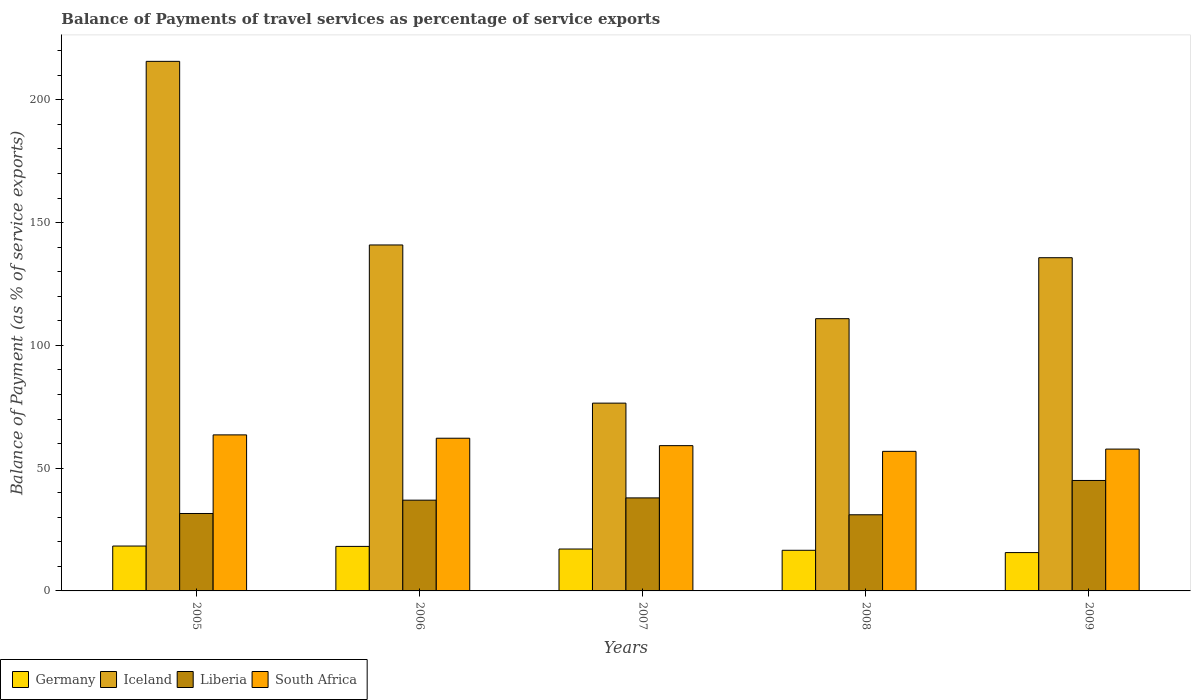How many different coloured bars are there?
Offer a terse response. 4. How many groups of bars are there?
Your answer should be compact. 5. What is the label of the 4th group of bars from the left?
Provide a succinct answer. 2008. What is the balance of payments of travel services in Germany in 2008?
Make the answer very short. 16.55. Across all years, what is the maximum balance of payments of travel services in South Africa?
Your response must be concise. 63.54. Across all years, what is the minimum balance of payments of travel services in South Africa?
Provide a short and direct response. 56.83. In which year was the balance of payments of travel services in Iceland minimum?
Give a very brief answer. 2007. What is the total balance of payments of travel services in Germany in the graph?
Give a very brief answer. 85.63. What is the difference between the balance of payments of travel services in Germany in 2005 and that in 2007?
Offer a terse response. 1.21. What is the difference between the balance of payments of travel services in Germany in 2005 and the balance of payments of travel services in Iceland in 2006?
Ensure brevity in your answer.  -122.6. What is the average balance of payments of travel services in Iceland per year?
Provide a succinct answer. 135.91. In the year 2009, what is the difference between the balance of payments of travel services in South Africa and balance of payments of travel services in Germany?
Provide a succinct answer. 42.15. In how many years, is the balance of payments of travel services in Liberia greater than 200 %?
Offer a very short reply. 0. What is the ratio of the balance of payments of travel services in Germany in 2005 to that in 2008?
Ensure brevity in your answer.  1.1. Is the balance of payments of travel services in Germany in 2005 less than that in 2007?
Provide a short and direct response. No. What is the difference between the highest and the second highest balance of payments of travel services in Germany?
Provide a short and direct response. 0.14. What is the difference between the highest and the lowest balance of payments of travel services in Germany?
Your answer should be very brief. 2.67. What does the 4th bar from the left in 2009 represents?
Offer a terse response. South Africa. What does the 3rd bar from the right in 2008 represents?
Your answer should be compact. Iceland. How many bars are there?
Make the answer very short. 20. Are all the bars in the graph horizontal?
Provide a succinct answer. No. How many years are there in the graph?
Give a very brief answer. 5. Are the values on the major ticks of Y-axis written in scientific E-notation?
Offer a terse response. No. Does the graph contain grids?
Ensure brevity in your answer.  No. Where does the legend appear in the graph?
Offer a terse response. Bottom left. How are the legend labels stacked?
Provide a succinct answer. Horizontal. What is the title of the graph?
Keep it short and to the point. Balance of Payments of travel services as percentage of service exports. What is the label or title of the X-axis?
Keep it short and to the point. Years. What is the label or title of the Y-axis?
Provide a short and direct response. Balance of Payment (as % of service exports). What is the Balance of Payment (as % of service exports) of Germany in 2005?
Make the answer very short. 18.28. What is the Balance of Payment (as % of service exports) in Iceland in 2005?
Your response must be concise. 215.64. What is the Balance of Payment (as % of service exports) of Liberia in 2005?
Provide a succinct answer. 31.53. What is the Balance of Payment (as % of service exports) in South Africa in 2005?
Ensure brevity in your answer.  63.54. What is the Balance of Payment (as % of service exports) of Germany in 2006?
Offer a very short reply. 18.13. What is the Balance of Payment (as % of service exports) of Iceland in 2006?
Keep it short and to the point. 140.88. What is the Balance of Payment (as % of service exports) in Liberia in 2006?
Offer a very short reply. 36.96. What is the Balance of Payment (as % of service exports) in South Africa in 2006?
Offer a very short reply. 62.18. What is the Balance of Payment (as % of service exports) of Germany in 2007?
Make the answer very short. 17.06. What is the Balance of Payment (as % of service exports) of Iceland in 2007?
Ensure brevity in your answer.  76.47. What is the Balance of Payment (as % of service exports) of Liberia in 2007?
Ensure brevity in your answer.  37.88. What is the Balance of Payment (as % of service exports) of South Africa in 2007?
Make the answer very short. 59.16. What is the Balance of Payment (as % of service exports) of Germany in 2008?
Your answer should be compact. 16.55. What is the Balance of Payment (as % of service exports) in Iceland in 2008?
Provide a short and direct response. 110.86. What is the Balance of Payment (as % of service exports) in Liberia in 2008?
Your answer should be compact. 31.01. What is the Balance of Payment (as % of service exports) in South Africa in 2008?
Provide a succinct answer. 56.83. What is the Balance of Payment (as % of service exports) in Germany in 2009?
Keep it short and to the point. 15.61. What is the Balance of Payment (as % of service exports) in Iceland in 2009?
Your response must be concise. 135.69. What is the Balance of Payment (as % of service exports) of Liberia in 2009?
Give a very brief answer. 44.98. What is the Balance of Payment (as % of service exports) of South Africa in 2009?
Ensure brevity in your answer.  57.76. Across all years, what is the maximum Balance of Payment (as % of service exports) of Germany?
Provide a short and direct response. 18.28. Across all years, what is the maximum Balance of Payment (as % of service exports) of Iceland?
Offer a terse response. 215.64. Across all years, what is the maximum Balance of Payment (as % of service exports) in Liberia?
Your answer should be very brief. 44.98. Across all years, what is the maximum Balance of Payment (as % of service exports) in South Africa?
Your answer should be very brief. 63.54. Across all years, what is the minimum Balance of Payment (as % of service exports) of Germany?
Ensure brevity in your answer.  15.61. Across all years, what is the minimum Balance of Payment (as % of service exports) in Iceland?
Your answer should be very brief. 76.47. Across all years, what is the minimum Balance of Payment (as % of service exports) in Liberia?
Keep it short and to the point. 31.01. Across all years, what is the minimum Balance of Payment (as % of service exports) of South Africa?
Your answer should be compact. 56.83. What is the total Balance of Payment (as % of service exports) in Germany in the graph?
Your answer should be compact. 85.63. What is the total Balance of Payment (as % of service exports) of Iceland in the graph?
Offer a terse response. 679.54. What is the total Balance of Payment (as % of service exports) in Liberia in the graph?
Your answer should be compact. 182.36. What is the total Balance of Payment (as % of service exports) in South Africa in the graph?
Provide a succinct answer. 299.47. What is the difference between the Balance of Payment (as % of service exports) in Germany in 2005 and that in 2006?
Offer a terse response. 0.14. What is the difference between the Balance of Payment (as % of service exports) in Iceland in 2005 and that in 2006?
Your response must be concise. 74.77. What is the difference between the Balance of Payment (as % of service exports) in Liberia in 2005 and that in 2006?
Provide a succinct answer. -5.43. What is the difference between the Balance of Payment (as % of service exports) of South Africa in 2005 and that in 2006?
Provide a short and direct response. 1.36. What is the difference between the Balance of Payment (as % of service exports) of Germany in 2005 and that in 2007?
Your answer should be compact. 1.21. What is the difference between the Balance of Payment (as % of service exports) of Iceland in 2005 and that in 2007?
Offer a very short reply. 139.18. What is the difference between the Balance of Payment (as % of service exports) in Liberia in 2005 and that in 2007?
Offer a terse response. -6.35. What is the difference between the Balance of Payment (as % of service exports) of South Africa in 2005 and that in 2007?
Your answer should be compact. 4.38. What is the difference between the Balance of Payment (as % of service exports) in Germany in 2005 and that in 2008?
Provide a succinct answer. 1.73. What is the difference between the Balance of Payment (as % of service exports) of Iceland in 2005 and that in 2008?
Ensure brevity in your answer.  104.78. What is the difference between the Balance of Payment (as % of service exports) of Liberia in 2005 and that in 2008?
Provide a short and direct response. 0.52. What is the difference between the Balance of Payment (as % of service exports) of South Africa in 2005 and that in 2008?
Give a very brief answer. 6.71. What is the difference between the Balance of Payment (as % of service exports) of Germany in 2005 and that in 2009?
Keep it short and to the point. 2.67. What is the difference between the Balance of Payment (as % of service exports) in Iceland in 2005 and that in 2009?
Keep it short and to the point. 79.96. What is the difference between the Balance of Payment (as % of service exports) in Liberia in 2005 and that in 2009?
Provide a succinct answer. -13.45. What is the difference between the Balance of Payment (as % of service exports) of South Africa in 2005 and that in 2009?
Your answer should be compact. 5.78. What is the difference between the Balance of Payment (as % of service exports) of Germany in 2006 and that in 2007?
Your answer should be compact. 1.07. What is the difference between the Balance of Payment (as % of service exports) of Iceland in 2006 and that in 2007?
Keep it short and to the point. 64.41. What is the difference between the Balance of Payment (as % of service exports) in Liberia in 2006 and that in 2007?
Give a very brief answer. -0.92. What is the difference between the Balance of Payment (as % of service exports) in South Africa in 2006 and that in 2007?
Your response must be concise. 3.02. What is the difference between the Balance of Payment (as % of service exports) of Germany in 2006 and that in 2008?
Offer a very short reply. 1.58. What is the difference between the Balance of Payment (as % of service exports) of Iceland in 2006 and that in 2008?
Your response must be concise. 30.02. What is the difference between the Balance of Payment (as % of service exports) of Liberia in 2006 and that in 2008?
Your response must be concise. 5.95. What is the difference between the Balance of Payment (as % of service exports) of South Africa in 2006 and that in 2008?
Your response must be concise. 5.34. What is the difference between the Balance of Payment (as % of service exports) of Germany in 2006 and that in 2009?
Give a very brief answer. 2.52. What is the difference between the Balance of Payment (as % of service exports) of Iceland in 2006 and that in 2009?
Offer a very short reply. 5.19. What is the difference between the Balance of Payment (as % of service exports) in Liberia in 2006 and that in 2009?
Offer a terse response. -8.02. What is the difference between the Balance of Payment (as % of service exports) of South Africa in 2006 and that in 2009?
Give a very brief answer. 4.42. What is the difference between the Balance of Payment (as % of service exports) of Germany in 2007 and that in 2008?
Your answer should be compact. 0.51. What is the difference between the Balance of Payment (as % of service exports) in Iceland in 2007 and that in 2008?
Offer a very short reply. -34.39. What is the difference between the Balance of Payment (as % of service exports) of Liberia in 2007 and that in 2008?
Give a very brief answer. 6.87. What is the difference between the Balance of Payment (as % of service exports) of South Africa in 2007 and that in 2008?
Ensure brevity in your answer.  2.32. What is the difference between the Balance of Payment (as % of service exports) of Germany in 2007 and that in 2009?
Provide a succinct answer. 1.45. What is the difference between the Balance of Payment (as % of service exports) of Iceland in 2007 and that in 2009?
Offer a very short reply. -59.22. What is the difference between the Balance of Payment (as % of service exports) of Liberia in 2007 and that in 2009?
Provide a succinct answer. -7.1. What is the difference between the Balance of Payment (as % of service exports) of South Africa in 2007 and that in 2009?
Provide a succinct answer. 1.4. What is the difference between the Balance of Payment (as % of service exports) of Germany in 2008 and that in 2009?
Give a very brief answer. 0.94. What is the difference between the Balance of Payment (as % of service exports) of Iceland in 2008 and that in 2009?
Your answer should be very brief. -24.83. What is the difference between the Balance of Payment (as % of service exports) of Liberia in 2008 and that in 2009?
Offer a very short reply. -13.97. What is the difference between the Balance of Payment (as % of service exports) in South Africa in 2008 and that in 2009?
Give a very brief answer. -0.92. What is the difference between the Balance of Payment (as % of service exports) of Germany in 2005 and the Balance of Payment (as % of service exports) of Iceland in 2006?
Make the answer very short. -122.6. What is the difference between the Balance of Payment (as % of service exports) of Germany in 2005 and the Balance of Payment (as % of service exports) of Liberia in 2006?
Ensure brevity in your answer.  -18.68. What is the difference between the Balance of Payment (as % of service exports) in Germany in 2005 and the Balance of Payment (as % of service exports) in South Africa in 2006?
Provide a succinct answer. -43.9. What is the difference between the Balance of Payment (as % of service exports) in Iceland in 2005 and the Balance of Payment (as % of service exports) in Liberia in 2006?
Your answer should be compact. 178.69. What is the difference between the Balance of Payment (as % of service exports) in Iceland in 2005 and the Balance of Payment (as % of service exports) in South Africa in 2006?
Make the answer very short. 153.47. What is the difference between the Balance of Payment (as % of service exports) of Liberia in 2005 and the Balance of Payment (as % of service exports) of South Africa in 2006?
Your answer should be very brief. -30.65. What is the difference between the Balance of Payment (as % of service exports) in Germany in 2005 and the Balance of Payment (as % of service exports) in Iceland in 2007?
Offer a very short reply. -58.19. What is the difference between the Balance of Payment (as % of service exports) of Germany in 2005 and the Balance of Payment (as % of service exports) of Liberia in 2007?
Your answer should be very brief. -19.61. What is the difference between the Balance of Payment (as % of service exports) of Germany in 2005 and the Balance of Payment (as % of service exports) of South Africa in 2007?
Make the answer very short. -40.88. What is the difference between the Balance of Payment (as % of service exports) of Iceland in 2005 and the Balance of Payment (as % of service exports) of Liberia in 2007?
Offer a terse response. 177.76. What is the difference between the Balance of Payment (as % of service exports) of Iceland in 2005 and the Balance of Payment (as % of service exports) of South Africa in 2007?
Your response must be concise. 156.49. What is the difference between the Balance of Payment (as % of service exports) in Liberia in 2005 and the Balance of Payment (as % of service exports) in South Africa in 2007?
Offer a terse response. -27.63. What is the difference between the Balance of Payment (as % of service exports) in Germany in 2005 and the Balance of Payment (as % of service exports) in Iceland in 2008?
Give a very brief answer. -92.58. What is the difference between the Balance of Payment (as % of service exports) of Germany in 2005 and the Balance of Payment (as % of service exports) of Liberia in 2008?
Provide a short and direct response. -12.73. What is the difference between the Balance of Payment (as % of service exports) of Germany in 2005 and the Balance of Payment (as % of service exports) of South Africa in 2008?
Provide a succinct answer. -38.56. What is the difference between the Balance of Payment (as % of service exports) of Iceland in 2005 and the Balance of Payment (as % of service exports) of Liberia in 2008?
Provide a succinct answer. 184.64. What is the difference between the Balance of Payment (as % of service exports) of Iceland in 2005 and the Balance of Payment (as % of service exports) of South Africa in 2008?
Your response must be concise. 158.81. What is the difference between the Balance of Payment (as % of service exports) of Liberia in 2005 and the Balance of Payment (as % of service exports) of South Africa in 2008?
Offer a very short reply. -25.3. What is the difference between the Balance of Payment (as % of service exports) in Germany in 2005 and the Balance of Payment (as % of service exports) in Iceland in 2009?
Ensure brevity in your answer.  -117.41. What is the difference between the Balance of Payment (as % of service exports) in Germany in 2005 and the Balance of Payment (as % of service exports) in Liberia in 2009?
Give a very brief answer. -26.7. What is the difference between the Balance of Payment (as % of service exports) in Germany in 2005 and the Balance of Payment (as % of service exports) in South Africa in 2009?
Offer a terse response. -39.48. What is the difference between the Balance of Payment (as % of service exports) in Iceland in 2005 and the Balance of Payment (as % of service exports) in Liberia in 2009?
Ensure brevity in your answer.  170.67. What is the difference between the Balance of Payment (as % of service exports) in Iceland in 2005 and the Balance of Payment (as % of service exports) in South Africa in 2009?
Your response must be concise. 157.89. What is the difference between the Balance of Payment (as % of service exports) in Liberia in 2005 and the Balance of Payment (as % of service exports) in South Africa in 2009?
Make the answer very short. -26.23. What is the difference between the Balance of Payment (as % of service exports) in Germany in 2006 and the Balance of Payment (as % of service exports) in Iceland in 2007?
Make the answer very short. -58.34. What is the difference between the Balance of Payment (as % of service exports) of Germany in 2006 and the Balance of Payment (as % of service exports) of Liberia in 2007?
Your response must be concise. -19.75. What is the difference between the Balance of Payment (as % of service exports) of Germany in 2006 and the Balance of Payment (as % of service exports) of South Africa in 2007?
Your answer should be compact. -41.03. What is the difference between the Balance of Payment (as % of service exports) in Iceland in 2006 and the Balance of Payment (as % of service exports) in Liberia in 2007?
Keep it short and to the point. 102.99. What is the difference between the Balance of Payment (as % of service exports) in Iceland in 2006 and the Balance of Payment (as % of service exports) in South Africa in 2007?
Your answer should be compact. 81.72. What is the difference between the Balance of Payment (as % of service exports) in Liberia in 2006 and the Balance of Payment (as % of service exports) in South Africa in 2007?
Your answer should be compact. -22.2. What is the difference between the Balance of Payment (as % of service exports) of Germany in 2006 and the Balance of Payment (as % of service exports) of Iceland in 2008?
Your response must be concise. -92.73. What is the difference between the Balance of Payment (as % of service exports) in Germany in 2006 and the Balance of Payment (as % of service exports) in Liberia in 2008?
Your answer should be very brief. -12.88. What is the difference between the Balance of Payment (as % of service exports) in Germany in 2006 and the Balance of Payment (as % of service exports) in South Africa in 2008?
Provide a short and direct response. -38.7. What is the difference between the Balance of Payment (as % of service exports) in Iceland in 2006 and the Balance of Payment (as % of service exports) in Liberia in 2008?
Provide a short and direct response. 109.87. What is the difference between the Balance of Payment (as % of service exports) of Iceland in 2006 and the Balance of Payment (as % of service exports) of South Africa in 2008?
Provide a succinct answer. 84.04. What is the difference between the Balance of Payment (as % of service exports) in Liberia in 2006 and the Balance of Payment (as % of service exports) in South Africa in 2008?
Ensure brevity in your answer.  -19.88. What is the difference between the Balance of Payment (as % of service exports) in Germany in 2006 and the Balance of Payment (as % of service exports) in Iceland in 2009?
Your answer should be compact. -117.55. What is the difference between the Balance of Payment (as % of service exports) in Germany in 2006 and the Balance of Payment (as % of service exports) in Liberia in 2009?
Your response must be concise. -26.85. What is the difference between the Balance of Payment (as % of service exports) in Germany in 2006 and the Balance of Payment (as % of service exports) in South Africa in 2009?
Your answer should be very brief. -39.63. What is the difference between the Balance of Payment (as % of service exports) in Iceland in 2006 and the Balance of Payment (as % of service exports) in Liberia in 2009?
Give a very brief answer. 95.9. What is the difference between the Balance of Payment (as % of service exports) of Iceland in 2006 and the Balance of Payment (as % of service exports) of South Africa in 2009?
Make the answer very short. 83.12. What is the difference between the Balance of Payment (as % of service exports) in Liberia in 2006 and the Balance of Payment (as % of service exports) in South Africa in 2009?
Give a very brief answer. -20.8. What is the difference between the Balance of Payment (as % of service exports) in Germany in 2007 and the Balance of Payment (as % of service exports) in Iceland in 2008?
Ensure brevity in your answer.  -93.8. What is the difference between the Balance of Payment (as % of service exports) in Germany in 2007 and the Balance of Payment (as % of service exports) in Liberia in 2008?
Offer a terse response. -13.95. What is the difference between the Balance of Payment (as % of service exports) of Germany in 2007 and the Balance of Payment (as % of service exports) of South Africa in 2008?
Keep it short and to the point. -39.77. What is the difference between the Balance of Payment (as % of service exports) of Iceland in 2007 and the Balance of Payment (as % of service exports) of Liberia in 2008?
Your answer should be very brief. 45.46. What is the difference between the Balance of Payment (as % of service exports) of Iceland in 2007 and the Balance of Payment (as % of service exports) of South Africa in 2008?
Make the answer very short. 19.63. What is the difference between the Balance of Payment (as % of service exports) in Liberia in 2007 and the Balance of Payment (as % of service exports) in South Africa in 2008?
Your response must be concise. -18.95. What is the difference between the Balance of Payment (as % of service exports) in Germany in 2007 and the Balance of Payment (as % of service exports) in Iceland in 2009?
Ensure brevity in your answer.  -118.62. What is the difference between the Balance of Payment (as % of service exports) in Germany in 2007 and the Balance of Payment (as % of service exports) in Liberia in 2009?
Your answer should be compact. -27.92. What is the difference between the Balance of Payment (as % of service exports) in Germany in 2007 and the Balance of Payment (as % of service exports) in South Africa in 2009?
Make the answer very short. -40.7. What is the difference between the Balance of Payment (as % of service exports) of Iceland in 2007 and the Balance of Payment (as % of service exports) of Liberia in 2009?
Make the answer very short. 31.49. What is the difference between the Balance of Payment (as % of service exports) in Iceland in 2007 and the Balance of Payment (as % of service exports) in South Africa in 2009?
Provide a short and direct response. 18.71. What is the difference between the Balance of Payment (as % of service exports) in Liberia in 2007 and the Balance of Payment (as % of service exports) in South Africa in 2009?
Provide a succinct answer. -19.88. What is the difference between the Balance of Payment (as % of service exports) in Germany in 2008 and the Balance of Payment (as % of service exports) in Iceland in 2009?
Keep it short and to the point. -119.14. What is the difference between the Balance of Payment (as % of service exports) in Germany in 2008 and the Balance of Payment (as % of service exports) in Liberia in 2009?
Provide a short and direct response. -28.43. What is the difference between the Balance of Payment (as % of service exports) in Germany in 2008 and the Balance of Payment (as % of service exports) in South Africa in 2009?
Offer a terse response. -41.21. What is the difference between the Balance of Payment (as % of service exports) in Iceland in 2008 and the Balance of Payment (as % of service exports) in Liberia in 2009?
Ensure brevity in your answer.  65.88. What is the difference between the Balance of Payment (as % of service exports) in Iceland in 2008 and the Balance of Payment (as % of service exports) in South Africa in 2009?
Give a very brief answer. 53.1. What is the difference between the Balance of Payment (as % of service exports) in Liberia in 2008 and the Balance of Payment (as % of service exports) in South Africa in 2009?
Your answer should be very brief. -26.75. What is the average Balance of Payment (as % of service exports) in Germany per year?
Ensure brevity in your answer.  17.13. What is the average Balance of Payment (as % of service exports) in Iceland per year?
Your answer should be very brief. 135.91. What is the average Balance of Payment (as % of service exports) of Liberia per year?
Keep it short and to the point. 36.47. What is the average Balance of Payment (as % of service exports) of South Africa per year?
Offer a terse response. 59.89. In the year 2005, what is the difference between the Balance of Payment (as % of service exports) of Germany and Balance of Payment (as % of service exports) of Iceland?
Your answer should be compact. -197.37. In the year 2005, what is the difference between the Balance of Payment (as % of service exports) of Germany and Balance of Payment (as % of service exports) of Liberia?
Your answer should be compact. -13.26. In the year 2005, what is the difference between the Balance of Payment (as % of service exports) in Germany and Balance of Payment (as % of service exports) in South Africa?
Offer a terse response. -45.26. In the year 2005, what is the difference between the Balance of Payment (as % of service exports) in Iceland and Balance of Payment (as % of service exports) in Liberia?
Ensure brevity in your answer.  184.11. In the year 2005, what is the difference between the Balance of Payment (as % of service exports) in Iceland and Balance of Payment (as % of service exports) in South Africa?
Provide a short and direct response. 152.1. In the year 2005, what is the difference between the Balance of Payment (as % of service exports) in Liberia and Balance of Payment (as % of service exports) in South Africa?
Give a very brief answer. -32.01. In the year 2006, what is the difference between the Balance of Payment (as % of service exports) of Germany and Balance of Payment (as % of service exports) of Iceland?
Give a very brief answer. -122.74. In the year 2006, what is the difference between the Balance of Payment (as % of service exports) in Germany and Balance of Payment (as % of service exports) in Liberia?
Your answer should be compact. -18.83. In the year 2006, what is the difference between the Balance of Payment (as % of service exports) of Germany and Balance of Payment (as % of service exports) of South Africa?
Offer a terse response. -44.05. In the year 2006, what is the difference between the Balance of Payment (as % of service exports) in Iceland and Balance of Payment (as % of service exports) in Liberia?
Offer a very short reply. 103.92. In the year 2006, what is the difference between the Balance of Payment (as % of service exports) of Iceland and Balance of Payment (as % of service exports) of South Africa?
Provide a short and direct response. 78.7. In the year 2006, what is the difference between the Balance of Payment (as % of service exports) in Liberia and Balance of Payment (as % of service exports) in South Africa?
Your answer should be compact. -25.22. In the year 2007, what is the difference between the Balance of Payment (as % of service exports) of Germany and Balance of Payment (as % of service exports) of Iceland?
Give a very brief answer. -59.41. In the year 2007, what is the difference between the Balance of Payment (as % of service exports) of Germany and Balance of Payment (as % of service exports) of Liberia?
Keep it short and to the point. -20.82. In the year 2007, what is the difference between the Balance of Payment (as % of service exports) of Germany and Balance of Payment (as % of service exports) of South Africa?
Your answer should be very brief. -42.1. In the year 2007, what is the difference between the Balance of Payment (as % of service exports) of Iceland and Balance of Payment (as % of service exports) of Liberia?
Your response must be concise. 38.59. In the year 2007, what is the difference between the Balance of Payment (as % of service exports) of Iceland and Balance of Payment (as % of service exports) of South Africa?
Offer a very short reply. 17.31. In the year 2007, what is the difference between the Balance of Payment (as % of service exports) of Liberia and Balance of Payment (as % of service exports) of South Africa?
Provide a short and direct response. -21.28. In the year 2008, what is the difference between the Balance of Payment (as % of service exports) in Germany and Balance of Payment (as % of service exports) in Iceland?
Give a very brief answer. -94.31. In the year 2008, what is the difference between the Balance of Payment (as % of service exports) in Germany and Balance of Payment (as % of service exports) in Liberia?
Your response must be concise. -14.46. In the year 2008, what is the difference between the Balance of Payment (as % of service exports) of Germany and Balance of Payment (as % of service exports) of South Africa?
Your answer should be very brief. -40.29. In the year 2008, what is the difference between the Balance of Payment (as % of service exports) in Iceland and Balance of Payment (as % of service exports) in Liberia?
Keep it short and to the point. 79.85. In the year 2008, what is the difference between the Balance of Payment (as % of service exports) in Iceland and Balance of Payment (as % of service exports) in South Africa?
Your answer should be very brief. 54.03. In the year 2008, what is the difference between the Balance of Payment (as % of service exports) in Liberia and Balance of Payment (as % of service exports) in South Africa?
Offer a terse response. -25.83. In the year 2009, what is the difference between the Balance of Payment (as % of service exports) in Germany and Balance of Payment (as % of service exports) in Iceland?
Your answer should be compact. -120.08. In the year 2009, what is the difference between the Balance of Payment (as % of service exports) in Germany and Balance of Payment (as % of service exports) in Liberia?
Your answer should be very brief. -29.37. In the year 2009, what is the difference between the Balance of Payment (as % of service exports) in Germany and Balance of Payment (as % of service exports) in South Africa?
Your response must be concise. -42.15. In the year 2009, what is the difference between the Balance of Payment (as % of service exports) in Iceland and Balance of Payment (as % of service exports) in Liberia?
Your answer should be compact. 90.71. In the year 2009, what is the difference between the Balance of Payment (as % of service exports) in Iceland and Balance of Payment (as % of service exports) in South Africa?
Your response must be concise. 77.93. In the year 2009, what is the difference between the Balance of Payment (as % of service exports) of Liberia and Balance of Payment (as % of service exports) of South Africa?
Ensure brevity in your answer.  -12.78. What is the ratio of the Balance of Payment (as % of service exports) of Germany in 2005 to that in 2006?
Your answer should be compact. 1.01. What is the ratio of the Balance of Payment (as % of service exports) in Iceland in 2005 to that in 2006?
Offer a very short reply. 1.53. What is the ratio of the Balance of Payment (as % of service exports) in Liberia in 2005 to that in 2006?
Your answer should be compact. 0.85. What is the ratio of the Balance of Payment (as % of service exports) in South Africa in 2005 to that in 2006?
Offer a very short reply. 1.02. What is the ratio of the Balance of Payment (as % of service exports) of Germany in 2005 to that in 2007?
Make the answer very short. 1.07. What is the ratio of the Balance of Payment (as % of service exports) in Iceland in 2005 to that in 2007?
Give a very brief answer. 2.82. What is the ratio of the Balance of Payment (as % of service exports) in Liberia in 2005 to that in 2007?
Offer a very short reply. 0.83. What is the ratio of the Balance of Payment (as % of service exports) of South Africa in 2005 to that in 2007?
Provide a succinct answer. 1.07. What is the ratio of the Balance of Payment (as % of service exports) in Germany in 2005 to that in 2008?
Give a very brief answer. 1.1. What is the ratio of the Balance of Payment (as % of service exports) of Iceland in 2005 to that in 2008?
Provide a succinct answer. 1.95. What is the ratio of the Balance of Payment (as % of service exports) in Liberia in 2005 to that in 2008?
Provide a succinct answer. 1.02. What is the ratio of the Balance of Payment (as % of service exports) of South Africa in 2005 to that in 2008?
Your answer should be very brief. 1.12. What is the ratio of the Balance of Payment (as % of service exports) of Germany in 2005 to that in 2009?
Offer a terse response. 1.17. What is the ratio of the Balance of Payment (as % of service exports) of Iceland in 2005 to that in 2009?
Your answer should be very brief. 1.59. What is the ratio of the Balance of Payment (as % of service exports) in Liberia in 2005 to that in 2009?
Your answer should be compact. 0.7. What is the ratio of the Balance of Payment (as % of service exports) in South Africa in 2005 to that in 2009?
Make the answer very short. 1.1. What is the ratio of the Balance of Payment (as % of service exports) in Germany in 2006 to that in 2007?
Ensure brevity in your answer.  1.06. What is the ratio of the Balance of Payment (as % of service exports) of Iceland in 2006 to that in 2007?
Ensure brevity in your answer.  1.84. What is the ratio of the Balance of Payment (as % of service exports) in Liberia in 2006 to that in 2007?
Your response must be concise. 0.98. What is the ratio of the Balance of Payment (as % of service exports) of South Africa in 2006 to that in 2007?
Keep it short and to the point. 1.05. What is the ratio of the Balance of Payment (as % of service exports) of Germany in 2006 to that in 2008?
Offer a terse response. 1.1. What is the ratio of the Balance of Payment (as % of service exports) of Iceland in 2006 to that in 2008?
Your answer should be very brief. 1.27. What is the ratio of the Balance of Payment (as % of service exports) in Liberia in 2006 to that in 2008?
Your answer should be very brief. 1.19. What is the ratio of the Balance of Payment (as % of service exports) in South Africa in 2006 to that in 2008?
Make the answer very short. 1.09. What is the ratio of the Balance of Payment (as % of service exports) of Germany in 2006 to that in 2009?
Make the answer very short. 1.16. What is the ratio of the Balance of Payment (as % of service exports) of Iceland in 2006 to that in 2009?
Make the answer very short. 1.04. What is the ratio of the Balance of Payment (as % of service exports) of Liberia in 2006 to that in 2009?
Your response must be concise. 0.82. What is the ratio of the Balance of Payment (as % of service exports) of South Africa in 2006 to that in 2009?
Give a very brief answer. 1.08. What is the ratio of the Balance of Payment (as % of service exports) in Germany in 2007 to that in 2008?
Ensure brevity in your answer.  1.03. What is the ratio of the Balance of Payment (as % of service exports) in Iceland in 2007 to that in 2008?
Provide a short and direct response. 0.69. What is the ratio of the Balance of Payment (as % of service exports) in Liberia in 2007 to that in 2008?
Give a very brief answer. 1.22. What is the ratio of the Balance of Payment (as % of service exports) in South Africa in 2007 to that in 2008?
Give a very brief answer. 1.04. What is the ratio of the Balance of Payment (as % of service exports) of Germany in 2007 to that in 2009?
Your answer should be very brief. 1.09. What is the ratio of the Balance of Payment (as % of service exports) in Iceland in 2007 to that in 2009?
Provide a succinct answer. 0.56. What is the ratio of the Balance of Payment (as % of service exports) in Liberia in 2007 to that in 2009?
Provide a succinct answer. 0.84. What is the ratio of the Balance of Payment (as % of service exports) of South Africa in 2007 to that in 2009?
Give a very brief answer. 1.02. What is the ratio of the Balance of Payment (as % of service exports) of Germany in 2008 to that in 2009?
Offer a very short reply. 1.06. What is the ratio of the Balance of Payment (as % of service exports) of Iceland in 2008 to that in 2009?
Your response must be concise. 0.82. What is the ratio of the Balance of Payment (as % of service exports) in Liberia in 2008 to that in 2009?
Offer a very short reply. 0.69. What is the ratio of the Balance of Payment (as % of service exports) in South Africa in 2008 to that in 2009?
Your answer should be compact. 0.98. What is the difference between the highest and the second highest Balance of Payment (as % of service exports) in Germany?
Your response must be concise. 0.14. What is the difference between the highest and the second highest Balance of Payment (as % of service exports) in Iceland?
Offer a terse response. 74.77. What is the difference between the highest and the second highest Balance of Payment (as % of service exports) in Liberia?
Provide a short and direct response. 7.1. What is the difference between the highest and the second highest Balance of Payment (as % of service exports) in South Africa?
Keep it short and to the point. 1.36. What is the difference between the highest and the lowest Balance of Payment (as % of service exports) in Germany?
Provide a succinct answer. 2.67. What is the difference between the highest and the lowest Balance of Payment (as % of service exports) in Iceland?
Keep it short and to the point. 139.18. What is the difference between the highest and the lowest Balance of Payment (as % of service exports) of Liberia?
Your answer should be compact. 13.97. What is the difference between the highest and the lowest Balance of Payment (as % of service exports) of South Africa?
Give a very brief answer. 6.71. 